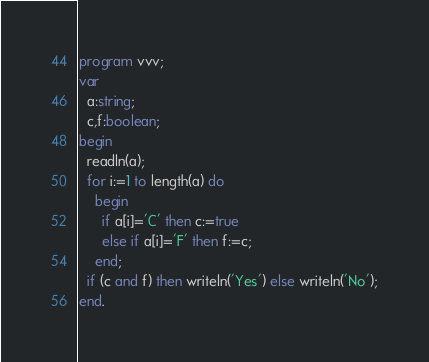<code> <loc_0><loc_0><loc_500><loc_500><_Pascal_>program vvv;
var
  a:string;
  c,f:boolean;
begin
  readln(a);
  for i:=1 to length(a) do
    begin
      if a[i]='C' then c:=true
      else if a[i]='F' then f:=c;
    end;
  if (c and f) then writeln('Yes') else writeln('No');
end.</code> 